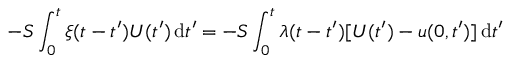Convert formula to latex. <formula><loc_0><loc_0><loc_500><loc_500>- S \int _ { 0 } ^ { t } \xi ( t - t ^ { \prime } ) U ( t ^ { \prime } ) \, d t ^ { \prime } = - S \int _ { 0 } ^ { t } \lambda ( t - t ^ { \prime } ) [ U ( t ^ { \prime } ) - u ( 0 , t ^ { \prime } ) ] \, d t ^ { \prime }</formula> 